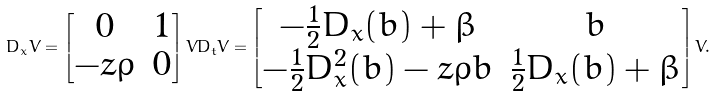Convert formula to latex. <formula><loc_0><loc_0><loc_500><loc_500>D _ { x } V = \begin{bmatrix} 0 & 1 \\ - z \rho & 0 \end{bmatrix} V D _ { t } V = \begin{bmatrix} - \frac { 1 } { 2 } D _ { x } ( b ) + \beta & b \\ - \frac { 1 } { 2 } D ^ { 2 } _ { x } ( b ) - z \rho b & \frac { 1 } { 2 } D _ { x } ( b ) + \beta \end{bmatrix} V .</formula> 